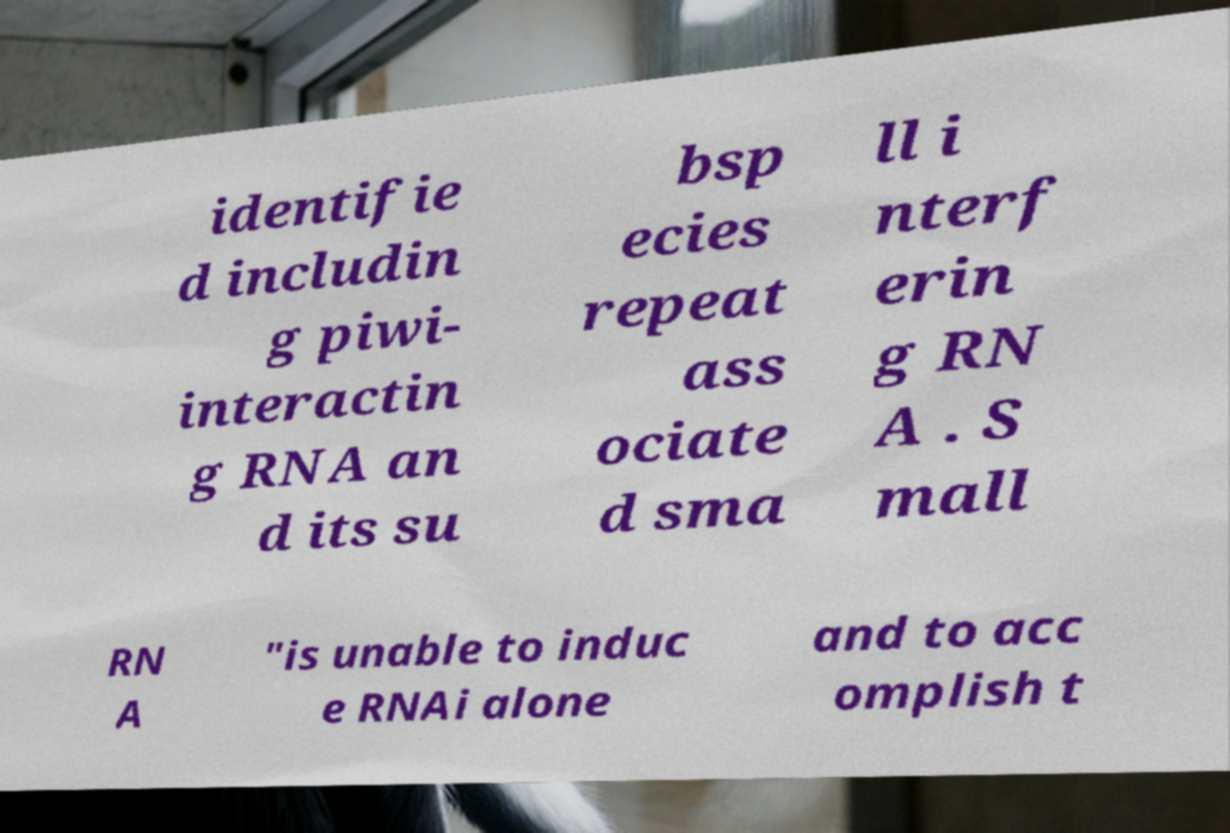Please read and relay the text visible in this image. What does it say? identifie d includin g piwi- interactin g RNA an d its su bsp ecies repeat ass ociate d sma ll i nterf erin g RN A . S mall RN A "is unable to induc e RNAi alone and to acc omplish t 